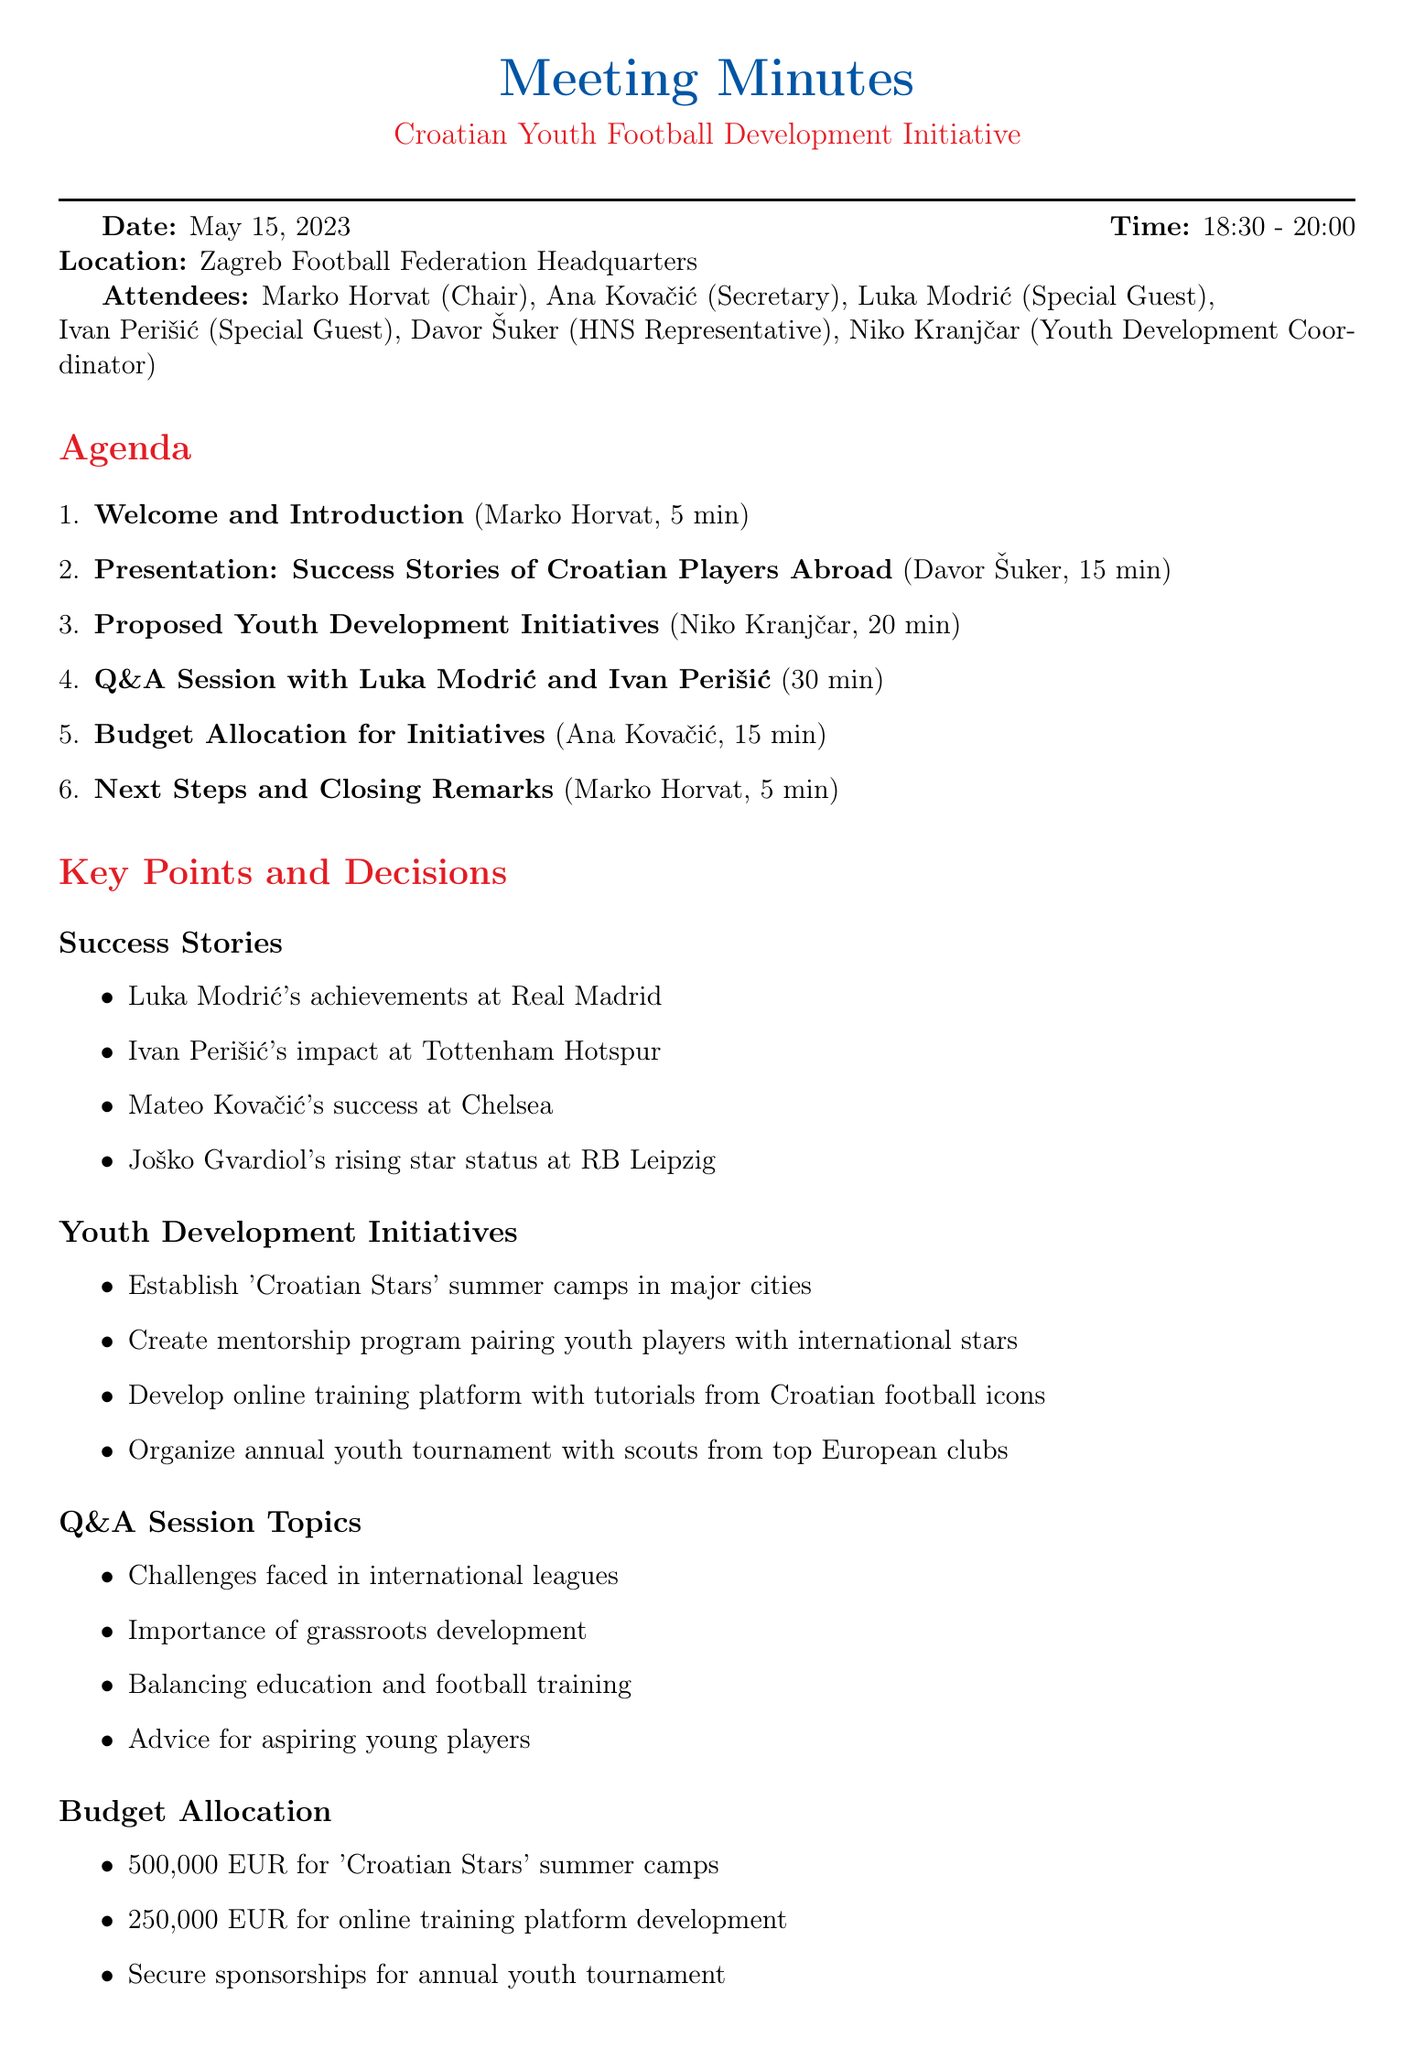What is the date of the meeting? The date of the meeting is clearly stated in the document as the day it occurred.
Answer: May 15, 2023 Who presented the success stories of Croatian players abroad? The document mentions the speaker for the presentation section and identifies the presenter.
Answer: Davor Šuker What is the budget allocated for the 'Croatian Stars' summer camps? The budget section provides specific financial allocations for different initiatives.
Answer: 500,000 EUR What initiative involves mentorship? The proposed initiatives include various development programs, one of which specifically focuses on mentorship.
Answer: Create mentorship program pairing youth players with international stars How long was the Q&A session with Luka Modrić and Ivan Perišić? The duration of each agenda item is noted in the document, particularly for the Q&A session.
Answer: 30 minutes What is one key topic discussed during the Q&A session? The document lists several key topics discussed during the Q&A, indicating the areas of focus.
Answer: Challenges faced in international leagues What is one of the next steps mentioned in the meeting? The action items at the end of the document summarize the follow-up actions decided upon in the meeting.
Answer: Form working groups for each initiative Who is the Youth Development Coordinator mentioned in the document? The attendees' section lists all participants, including their roles or titles, giving insight into their responsibilities.
Answer: Niko Kranjčar 